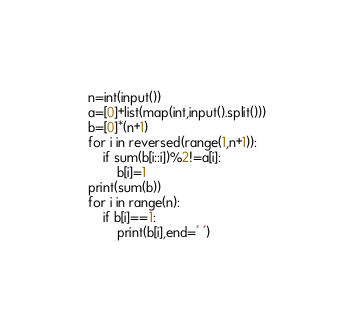Convert code to text. <code><loc_0><loc_0><loc_500><loc_500><_Python_>n=int(input())
a=[0]+list(map(int,input().split()))
b=[0]*(n+1)
for i in reversed(range(1,n+1)):
    if sum(b[i::i])%2!=a[i]:
        b[i]=1
print(sum(b))
for i in range(n):
    if b[i]==1:
        print(b[i],end=' ')</code> 